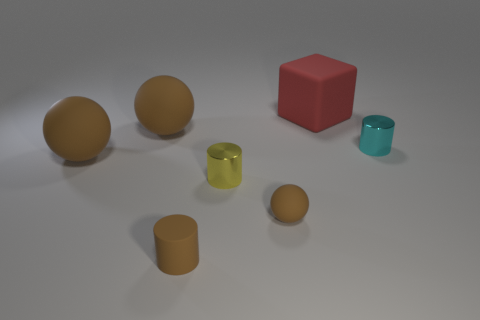Is the tiny cyan thing made of the same material as the red object?
Give a very brief answer. No. Is there any other thing that is the same shape as the large red object?
Ensure brevity in your answer.  No. There is a small cylinder that is in front of the metallic cylinder that is on the left side of the large matte block; what is its material?
Offer a very short reply. Rubber. There is a sphere that is behind the tiny cyan metallic cylinder; what size is it?
Ensure brevity in your answer.  Large. What is the color of the small cylinder that is to the left of the rubber block and behind the small brown rubber cylinder?
Offer a very short reply. Yellow. Do the thing right of the cube and the big matte block have the same size?
Your answer should be compact. No. Is there a brown rubber thing that is on the left side of the tiny shiny thing that is in front of the cyan shiny cylinder?
Your response must be concise. Yes. What is the material of the small brown sphere?
Your answer should be compact. Rubber. Are there any tiny cyan metal cylinders in front of the small brown sphere?
Provide a succinct answer. No. There is a matte object that is the same shape as the tiny cyan shiny object; what size is it?
Your answer should be very brief. Small. 